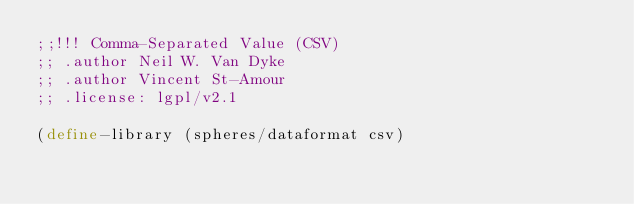<code> <loc_0><loc_0><loc_500><loc_500><_Scheme_>;;!!! Comma-Separated Value (CSV)
;; .author Neil W. Van Dyke
;; .author Vincent St-Amour
;; .license: lgpl/v2.1

(define-library (spheres/dataformat csv)</code> 